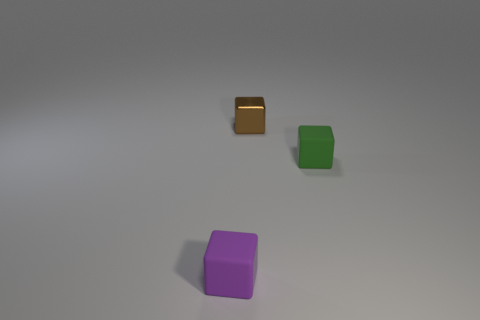Add 3 tiny purple objects. How many objects exist? 6 Subtract 0 red cylinders. How many objects are left? 3 Subtract all small green matte objects. Subtract all tiny brown cubes. How many objects are left? 1 Add 1 tiny purple objects. How many tiny purple objects are left? 2 Add 3 brown cubes. How many brown cubes exist? 4 